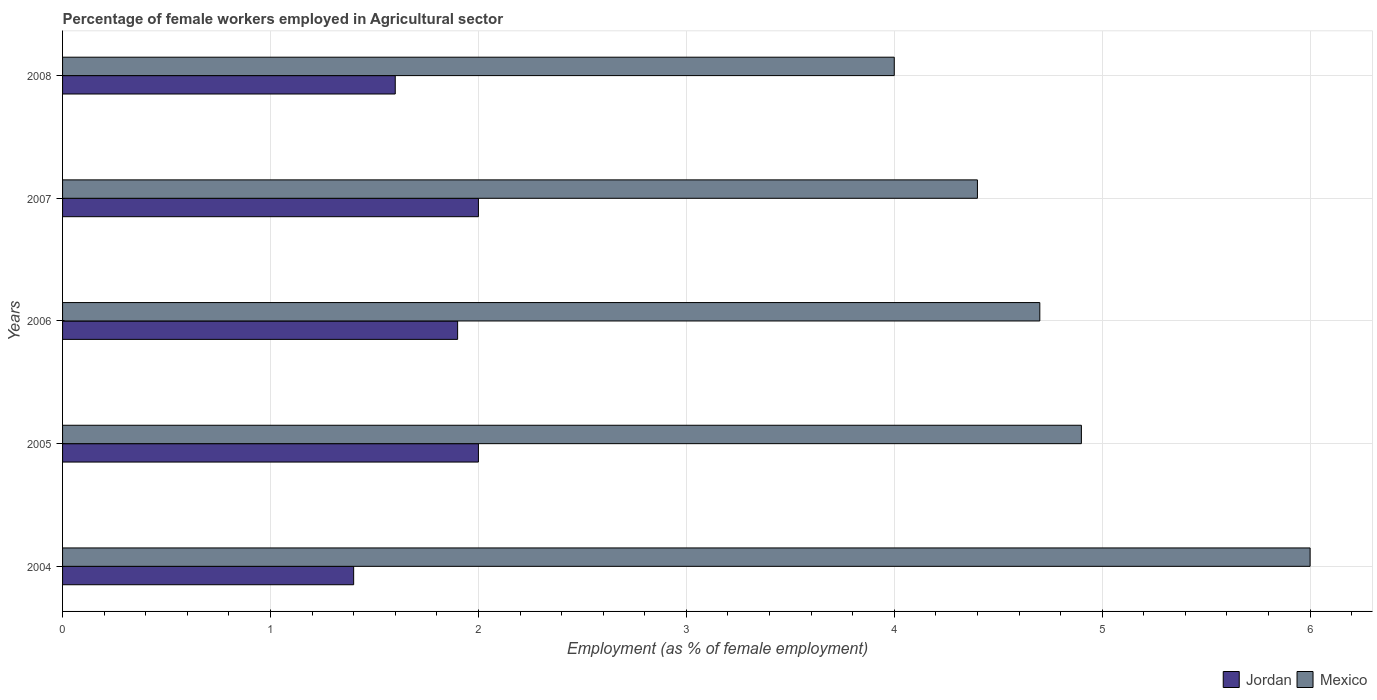How many different coloured bars are there?
Ensure brevity in your answer.  2. Are the number of bars per tick equal to the number of legend labels?
Ensure brevity in your answer.  Yes. How many bars are there on the 5th tick from the bottom?
Your answer should be very brief. 2. In how many cases, is the number of bars for a given year not equal to the number of legend labels?
Make the answer very short. 0. What is the percentage of females employed in Agricultural sector in Jordan in 2005?
Keep it short and to the point. 2. Across all years, what is the minimum percentage of females employed in Agricultural sector in Mexico?
Offer a terse response. 4. What is the difference between the percentage of females employed in Agricultural sector in Jordan in 2004 and that in 2008?
Give a very brief answer. -0.2. What is the average percentage of females employed in Agricultural sector in Jordan per year?
Provide a short and direct response. 1.78. In the year 2004, what is the difference between the percentage of females employed in Agricultural sector in Jordan and percentage of females employed in Agricultural sector in Mexico?
Offer a terse response. -4.6. In how many years, is the percentage of females employed in Agricultural sector in Jordan greater than 3.6 %?
Your answer should be very brief. 0. What is the ratio of the percentage of females employed in Agricultural sector in Jordan in 2007 to that in 2008?
Offer a terse response. 1.25. Is the difference between the percentage of females employed in Agricultural sector in Jordan in 2004 and 2006 greater than the difference between the percentage of females employed in Agricultural sector in Mexico in 2004 and 2006?
Offer a very short reply. No. What is the difference between the highest and the lowest percentage of females employed in Agricultural sector in Jordan?
Give a very brief answer. 0.6. Is the sum of the percentage of females employed in Agricultural sector in Mexico in 2004 and 2006 greater than the maximum percentage of females employed in Agricultural sector in Jordan across all years?
Give a very brief answer. Yes. What does the 1st bar from the bottom in 2004 represents?
Provide a short and direct response. Jordan. How many bars are there?
Your answer should be compact. 10. Are all the bars in the graph horizontal?
Your answer should be compact. Yes. How many years are there in the graph?
Provide a succinct answer. 5. What is the difference between two consecutive major ticks on the X-axis?
Provide a succinct answer. 1. Does the graph contain any zero values?
Your response must be concise. No. Does the graph contain grids?
Offer a terse response. Yes. Where does the legend appear in the graph?
Offer a very short reply. Bottom right. How are the legend labels stacked?
Provide a short and direct response. Horizontal. What is the title of the graph?
Offer a very short reply. Percentage of female workers employed in Agricultural sector. Does "High income: OECD" appear as one of the legend labels in the graph?
Offer a very short reply. No. What is the label or title of the X-axis?
Your answer should be very brief. Employment (as % of female employment). What is the Employment (as % of female employment) in Jordan in 2004?
Keep it short and to the point. 1.4. What is the Employment (as % of female employment) of Mexico in 2004?
Ensure brevity in your answer.  6. What is the Employment (as % of female employment) in Jordan in 2005?
Provide a short and direct response. 2. What is the Employment (as % of female employment) of Mexico in 2005?
Make the answer very short. 4.9. What is the Employment (as % of female employment) in Jordan in 2006?
Provide a short and direct response. 1.9. What is the Employment (as % of female employment) of Mexico in 2006?
Your answer should be compact. 4.7. What is the Employment (as % of female employment) in Mexico in 2007?
Make the answer very short. 4.4. What is the Employment (as % of female employment) in Jordan in 2008?
Your answer should be compact. 1.6. Across all years, what is the maximum Employment (as % of female employment) of Jordan?
Your response must be concise. 2. Across all years, what is the maximum Employment (as % of female employment) in Mexico?
Give a very brief answer. 6. Across all years, what is the minimum Employment (as % of female employment) of Jordan?
Offer a terse response. 1.4. What is the total Employment (as % of female employment) of Mexico in the graph?
Provide a succinct answer. 24. What is the difference between the Employment (as % of female employment) of Mexico in 2004 and that in 2005?
Provide a short and direct response. 1.1. What is the difference between the Employment (as % of female employment) in Jordan in 2004 and that in 2006?
Your answer should be compact. -0.5. What is the difference between the Employment (as % of female employment) of Jordan in 2004 and that in 2007?
Your answer should be compact. -0.6. What is the difference between the Employment (as % of female employment) in Mexico in 2004 and that in 2007?
Your response must be concise. 1.6. What is the difference between the Employment (as % of female employment) of Jordan in 2004 and that in 2008?
Make the answer very short. -0.2. What is the difference between the Employment (as % of female employment) of Mexico in 2004 and that in 2008?
Offer a terse response. 2. What is the difference between the Employment (as % of female employment) of Mexico in 2005 and that in 2006?
Offer a very short reply. 0.2. What is the difference between the Employment (as % of female employment) of Jordan in 2005 and that in 2007?
Offer a terse response. 0. What is the difference between the Employment (as % of female employment) in Mexico in 2005 and that in 2007?
Offer a terse response. 0.5. What is the difference between the Employment (as % of female employment) in Jordan in 2005 and that in 2008?
Offer a terse response. 0.4. What is the difference between the Employment (as % of female employment) of Jordan in 2006 and that in 2007?
Give a very brief answer. -0.1. What is the difference between the Employment (as % of female employment) of Mexico in 2006 and that in 2007?
Make the answer very short. 0.3. What is the difference between the Employment (as % of female employment) in Jordan in 2007 and that in 2008?
Provide a succinct answer. 0.4. What is the difference between the Employment (as % of female employment) in Mexico in 2007 and that in 2008?
Your response must be concise. 0.4. What is the difference between the Employment (as % of female employment) in Jordan in 2005 and the Employment (as % of female employment) in Mexico in 2007?
Offer a terse response. -2.4. What is the difference between the Employment (as % of female employment) in Jordan in 2006 and the Employment (as % of female employment) in Mexico in 2007?
Offer a terse response. -2.5. What is the difference between the Employment (as % of female employment) in Jordan in 2006 and the Employment (as % of female employment) in Mexico in 2008?
Give a very brief answer. -2.1. What is the average Employment (as % of female employment) of Jordan per year?
Your answer should be compact. 1.78. In the year 2004, what is the difference between the Employment (as % of female employment) of Jordan and Employment (as % of female employment) of Mexico?
Provide a short and direct response. -4.6. In the year 2005, what is the difference between the Employment (as % of female employment) of Jordan and Employment (as % of female employment) of Mexico?
Your answer should be very brief. -2.9. In the year 2006, what is the difference between the Employment (as % of female employment) in Jordan and Employment (as % of female employment) in Mexico?
Offer a terse response. -2.8. In the year 2007, what is the difference between the Employment (as % of female employment) of Jordan and Employment (as % of female employment) of Mexico?
Keep it short and to the point. -2.4. In the year 2008, what is the difference between the Employment (as % of female employment) of Jordan and Employment (as % of female employment) of Mexico?
Your answer should be compact. -2.4. What is the ratio of the Employment (as % of female employment) in Jordan in 2004 to that in 2005?
Make the answer very short. 0.7. What is the ratio of the Employment (as % of female employment) in Mexico in 2004 to that in 2005?
Offer a terse response. 1.22. What is the ratio of the Employment (as % of female employment) in Jordan in 2004 to that in 2006?
Offer a terse response. 0.74. What is the ratio of the Employment (as % of female employment) of Mexico in 2004 to that in 2006?
Offer a very short reply. 1.28. What is the ratio of the Employment (as % of female employment) of Mexico in 2004 to that in 2007?
Offer a terse response. 1.36. What is the ratio of the Employment (as % of female employment) in Jordan in 2004 to that in 2008?
Provide a succinct answer. 0.88. What is the ratio of the Employment (as % of female employment) of Jordan in 2005 to that in 2006?
Provide a short and direct response. 1.05. What is the ratio of the Employment (as % of female employment) in Mexico in 2005 to that in 2006?
Provide a succinct answer. 1.04. What is the ratio of the Employment (as % of female employment) in Jordan in 2005 to that in 2007?
Offer a very short reply. 1. What is the ratio of the Employment (as % of female employment) of Mexico in 2005 to that in 2007?
Provide a short and direct response. 1.11. What is the ratio of the Employment (as % of female employment) of Mexico in 2005 to that in 2008?
Make the answer very short. 1.23. What is the ratio of the Employment (as % of female employment) in Jordan in 2006 to that in 2007?
Offer a terse response. 0.95. What is the ratio of the Employment (as % of female employment) in Mexico in 2006 to that in 2007?
Your response must be concise. 1.07. What is the ratio of the Employment (as % of female employment) of Jordan in 2006 to that in 2008?
Ensure brevity in your answer.  1.19. What is the ratio of the Employment (as % of female employment) in Mexico in 2006 to that in 2008?
Your answer should be compact. 1.18. What is the difference between the highest and the lowest Employment (as % of female employment) of Jordan?
Ensure brevity in your answer.  0.6. What is the difference between the highest and the lowest Employment (as % of female employment) in Mexico?
Provide a succinct answer. 2. 